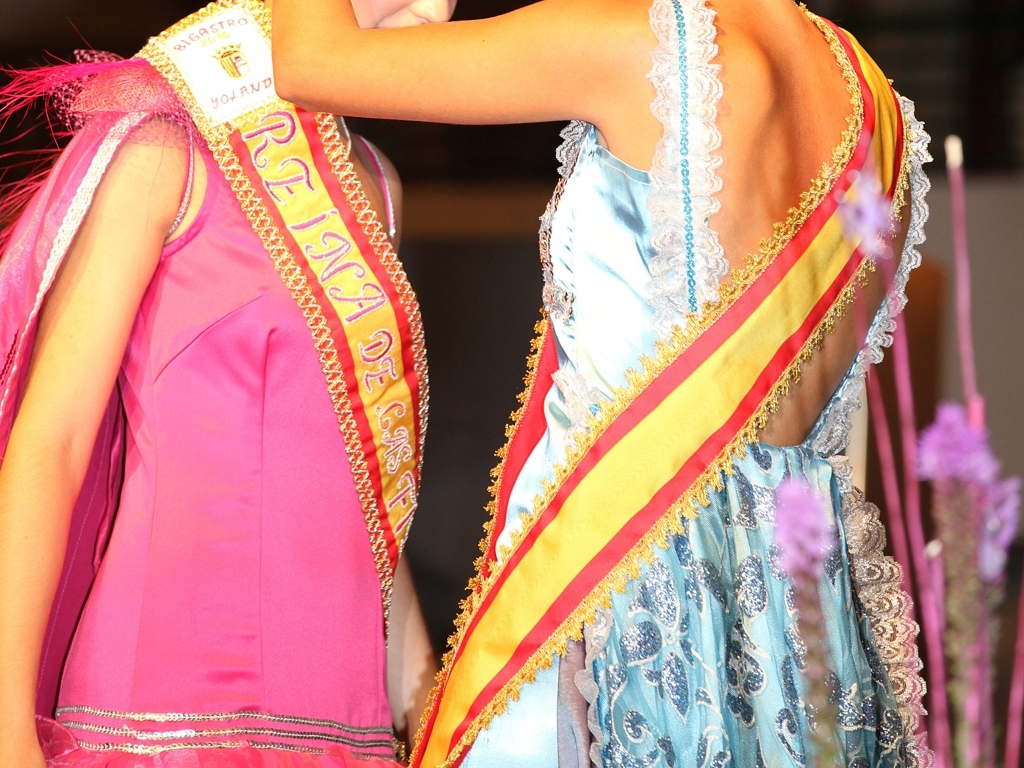What is the overall clarity of this image? A. The overall clarity of this image is high. B. The overall clarity of this image is low. Answer with the option's letter from the given choices directly. Option A is correct. The overall clarity of this image is high, as evidenced by the sharp details and vibrant colors, making the fine patterns on the fabrics and the sashes worn by the individuals easily visible. 